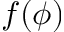<formula> <loc_0><loc_0><loc_500><loc_500>f ( \phi )</formula> 